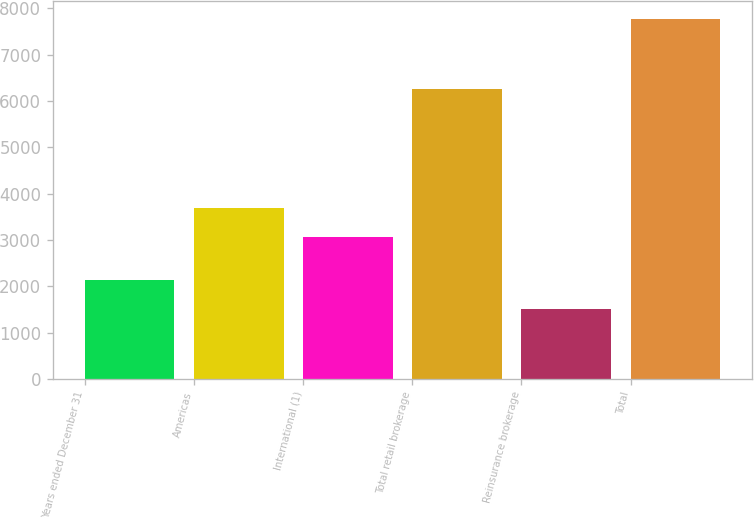Convert chart. <chart><loc_0><loc_0><loc_500><loc_500><bar_chart><fcel>Years ended December 31<fcel>Americas<fcel>International (1)<fcel>Total retail brokerage<fcel>Reinsurance brokerage<fcel>Total<nl><fcel>2130.6<fcel>3690.6<fcel>3065<fcel>6256<fcel>1505<fcel>7761<nl></chart> 